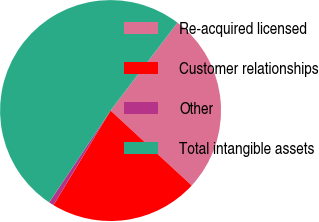Convert chart to OTSL. <chart><loc_0><loc_0><loc_500><loc_500><pie_chart><fcel>Re-acquired licensed<fcel>Customer relationships<fcel>Other<fcel>Total intangible assets<nl><fcel>26.51%<fcel>21.77%<fcel>0.74%<fcel>50.97%<nl></chart> 